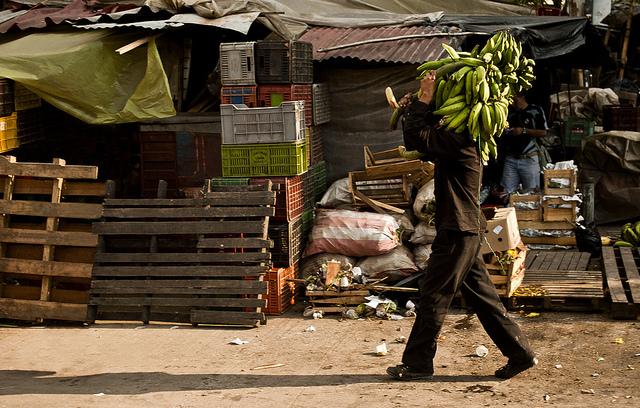Which are stacked higher, pallets or crates?
Keep it brief. Crates. What are those  on his shoulder?
Concise answer only. Bananas. Can you see shadow in this picture?
Write a very short answer. Yes. 